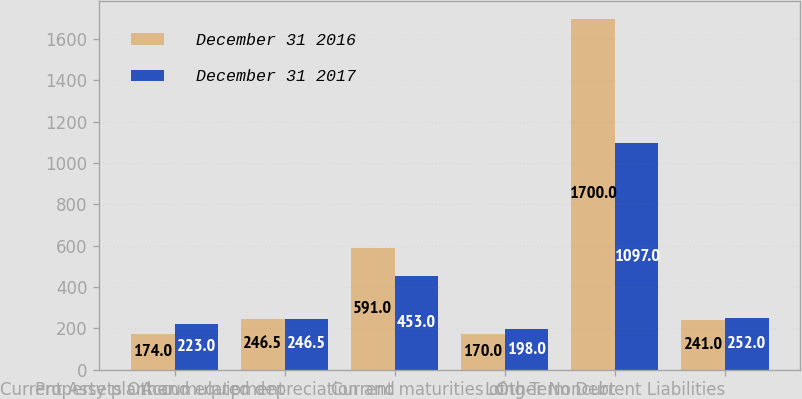Convert chart. <chart><loc_0><loc_0><loc_500><loc_500><stacked_bar_chart><ecel><fcel>Current Assets Other<fcel>Property plant and equipment<fcel>Accumulated depreciation and<fcel>Current maturities of<fcel>Long-Term Debt<fcel>Other Noncurrent Liabilities<nl><fcel>December 31 2016<fcel>174<fcel>246.5<fcel>591<fcel>170<fcel>1700<fcel>241<nl><fcel>December 31 2017<fcel>223<fcel>246.5<fcel>453<fcel>198<fcel>1097<fcel>252<nl></chart> 